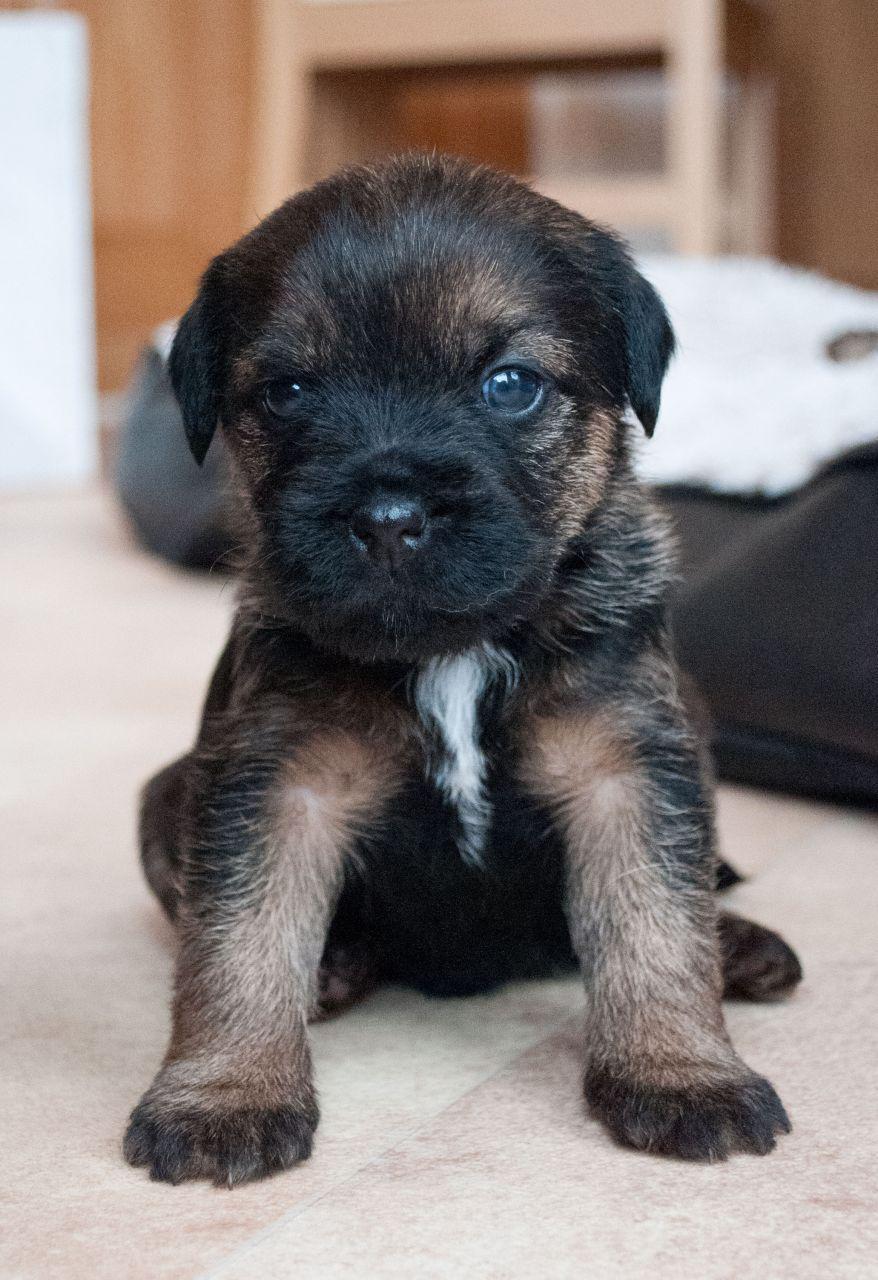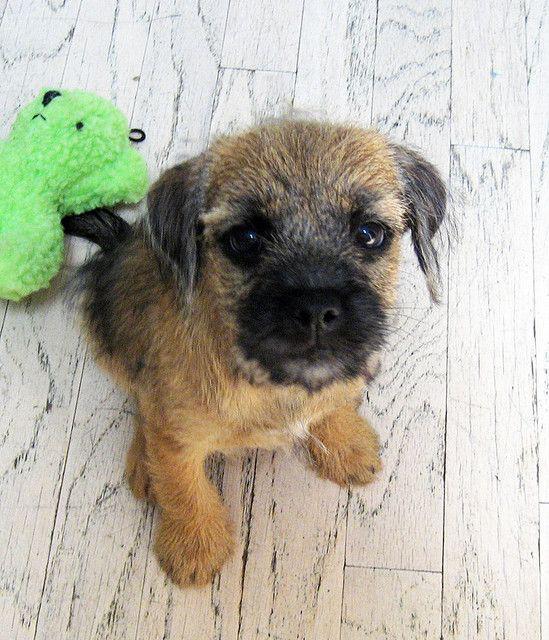The first image is the image on the left, the second image is the image on the right. Examine the images to the left and right. Is the description "Each image shows the face of one dog, but only the lefthand image features a dog with an open mouth." accurate? Answer yes or no. No. The first image is the image on the left, the second image is the image on the right. Considering the images on both sides, is "Each dog is outside in the grass." valid? Answer yes or no. No. 